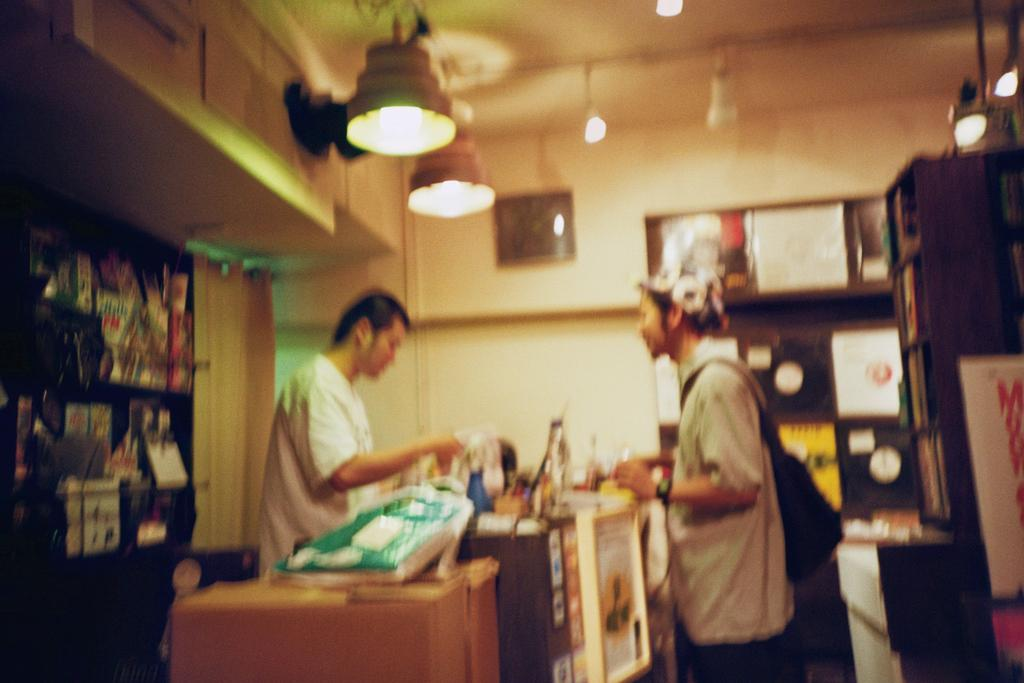How many people are present in the image? There are two people in the image. What else can be seen in the image besides the people? There are lights and posters in the image. What is the condition of the yard in the image? There is no yard present in the image; it only features two people, lights, and posters. Can you tell me how many hearts are visible in the image? There are no hearts present in the image. 